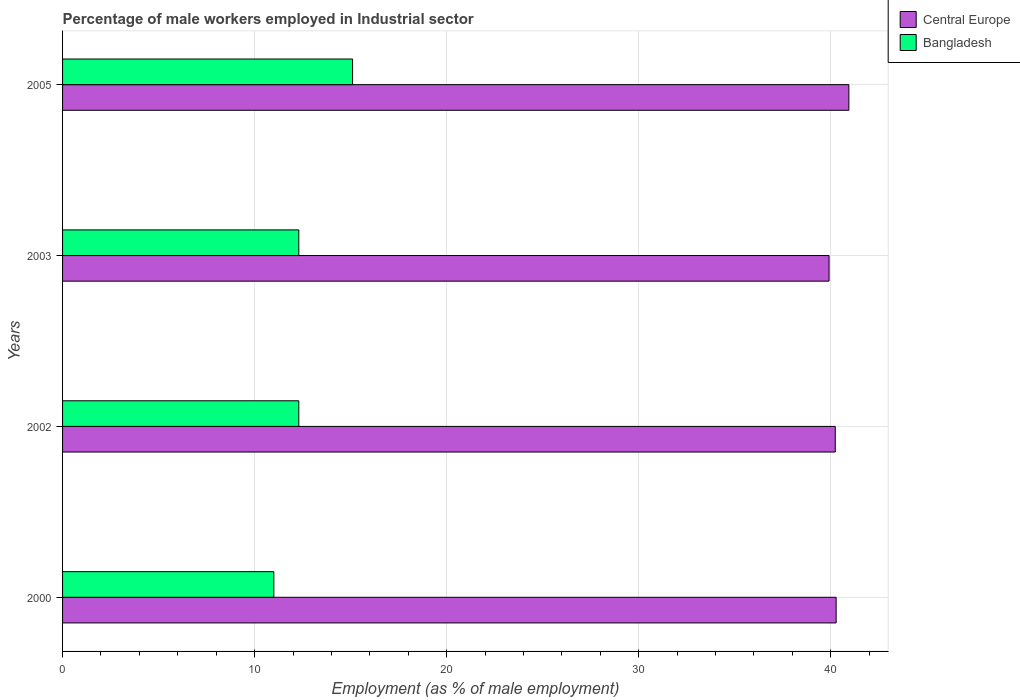How many groups of bars are there?
Provide a succinct answer. 4. Are the number of bars per tick equal to the number of legend labels?
Provide a succinct answer. Yes. In how many cases, is the number of bars for a given year not equal to the number of legend labels?
Make the answer very short. 0. What is the percentage of male workers employed in Industrial sector in Central Europe in 2005?
Offer a very short reply. 40.94. Across all years, what is the maximum percentage of male workers employed in Industrial sector in Bangladesh?
Your answer should be compact. 15.1. Across all years, what is the minimum percentage of male workers employed in Industrial sector in Central Europe?
Make the answer very short. 39.91. What is the total percentage of male workers employed in Industrial sector in Bangladesh in the graph?
Ensure brevity in your answer.  50.7. What is the difference between the percentage of male workers employed in Industrial sector in Bangladesh in 2003 and that in 2005?
Make the answer very short. -2.8. What is the difference between the percentage of male workers employed in Industrial sector in Bangladesh in 2000 and the percentage of male workers employed in Industrial sector in Central Europe in 2003?
Your response must be concise. -28.91. What is the average percentage of male workers employed in Industrial sector in Central Europe per year?
Make the answer very short. 40.34. In the year 2003, what is the difference between the percentage of male workers employed in Industrial sector in Bangladesh and percentage of male workers employed in Industrial sector in Central Europe?
Provide a succinct answer. -27.61. What is the ratio of the percentage of male workers employed in Industrial sector in Bangladesh in 2000 to that in 2002?
Your response must be concise. 0.89. Is the percentage of male workers employed in Industrial sector in Bangladesh in 2002 less than that in 2005?
Your answer should be compact. Yes. What is the difference between the highest and the second highest percentage of male workers employed in Industrial sector in Bangladesh?
Your response must be concise. 2.8. What is the difference between the highest and the lowest percentage of male workers employed in Industrial sector in Bangladesh?
Make the answer very short. 4.1. In how many years, is the percentage of male workers employed in Industrial sector in Bangladesh greater than the average percentage of male workers employed in Industrial sector in Bangladesh taken over all years?
Offer a very short reply. 1. What does the 2nd bar from the top in 2005 represents?
Ensure brevity in your answer.  Central Europe. What does the 2nd bar from the bottom in 2000 represents?
Make the answer very short. Bangladesh. How many years are there in the graph?
Ensure brevity in your answer.  4. Are the values on the major ticks of X-axis written in scientific E-notation?
Provide a succinct answer. No. Does the graph contain grids?
Give a very brief answer. Yes. Where does the legend appear in the graph?
Offer a terse response. Top right. How many legend labels are there?
Give a very brief answer. 2. What is the title of the graph?
Give a very brief answer. Percentage of male workers employed in Industrial sector. Does "Andorra" appear as one of the legend labels in the graph?
Ensure brevity in your answer.  No. What is the label or title of the X-axis?
Provide a short and direct response. Employment (as % of male employment). What is the Employment (as % of male employment) in Central Europe in 2000?
Give a very brief answer. 40.28. What is the Employment (as % of male employment) of Bangladesh in 2000?
Provide a short and direct response. 11. What is the Employment (as % of male employment) of Central Europe in 2002?
Make the answer very short. 40.23. What is the Employment (as % of male employment) of Bangladesh in 2002?
Keep it short and to the point. 12.3. What is the Employment (as % of male employment) in Central Europe in 2003?
Offer a very short reply. 39.91. What is the Employment (as % of male employment) of Bangladesh in 2003?
Give a very brief answer. 12.3. What is the Employment (as % of male employment) of Central Europe in 2005?
Keep it short and to the point. 40.94. What is the Employment (as % of male employment) in Bangladesh in 2005?
Make the answer very short. 15.1. Across all years, what is the maximum Employment (as % of male employment) of Central Europe?
Provide a succinct answer. 40.94. Across all years, what is the maximum Employment (as % of male employment) of Bangladesh?
Make the answer very short. 15.1. Across all years, what is the minimum Employment (as % of male employment) in Central Europe?
Provide a short and direct response. 39.91. What is the total Employment (as % of male employment) in Central Europe in the graph?
Provide a short and direct response. 161.36. What is the total Employment (as % of male employment) in Bangladesh in the graph?
Provide a short and direct response. 50.7. What is the difference between the Employment (as % of male employment) of Central Europe in 2000 and that in 2002?
Provide a succinct answer. 0.05. What is the difference between the Employment (as % of male employment) of Central Europe in 2000 and that in 2003?
Make the answer very short. 0.37. What is the difference between the Employment (as % of male employment) in Central Europe in 2000 and that in 2005?
Offer a very short reply. -0.66. What is the difference between the Employment (as % of male employment) of Bangladesh in 2000 and that in 2005?
Ensure brevity in your answer.  -4.1. What is the difference between the Employment (as % of male employment) in Central Europe in 2002 and that in 2003?
Give a very brief answer. 0.32. What is the difference between the Employment (as % of male employment) of Central Europe in 2002 and that in 2005?
Offer a terse response. -0.71. What is the difference between the Employment (as % of male employment) in Bangladesh in 2002 and that in 2005?
Provide a short and direct response. -2.8. What is the difference between the Employment (as % of male employment) of Central Europe in 2003 and that in 2005?
Your answer should be very brief. -1.03. What is the difference between the Employment (as % of male employment) of Central Europe in 2000 and the Employment (as % of male employment) of Bangladesh in 2002?
Make the answer very short. 27.98. What is the difference between the Employment (as % of male employment) in Central Europe in 2000 and the Employment (as % of male employment) in Bangladesh in 2003?
Offer a very short reply. 27.98. What is the difference between the Employment (as % of male employment) in Central Europe in 2000 and the Employment (as % of male employment) in Bangladesh in 2005?
Provide a succinct answer. 25.18. What is the difference between the Employment (as % of male employment) in Central Europe in 2002 and the Employment (as % of male employment) in Bangladesh in 2003?
Give a very brief answer. 27.93. What is the difference between the Employment (as % of male employment) in Central Europe in 2002 and the Employment (as % of male employment) in Bangladesh in 2005?
Offer a very short reply. 25.13. What is the difference between the Employment (as % of male employment) in Central Europe in 2003 and the Employment (as % of male employment) in Bangladesh in 2005?
Make the answer very short. 24.81. What is the average Employment (as % of male employment) in Central Europe per year?
Your response must be concise. 40.34. What is the average Employment (as % of male employment) of Bangladesh per year?
Ensure brevity in your answer.  12.68. In the year 2000, what is the difference between the Employment (as % of male employment) in Central Europe and Employment (as % of male employment) in Bangladesh?
Make the answer very short. 29.28. In the year 2002, what is the difference between the Employment (as % of male employment) in Central Europe and Employment (as % of male employment) in Bangladesh?
Keep it short and to the point. 27.93. In the year 2003, what is the difference between the Employment (as % of male employment) of Central Europe and Employment (as % of male employment) of Bangladesh?
Your answer should be compact. 27.61. In the year 2005, what is the difference between the Employment (as % of male employment) of Central Europe and Employment (as % of male employment) of Bangladesh?
Provide a succinct answer. 25.84. What is the ratio of the Employment (as % of male employment) of Central Europe in 2000 to that in 2002?
Make the answer very short. 1. What is the ratio of the Employment (as % of male employment) in Bangladesh in 2000 to that in 2002?
Your answer should be very brief. 0.89. What is the ratio of the Employment (as % of male employment) of Central Europe in 2000 to that in 2003?
Keep it short and to the point. 1.01. What is the ratio of the Employment (as % of male employment) in Bangladesh in 2000 to that in 2003?
Provide a succinct answer. 0.89. What is the ratio of the Employment (as % of male employment) of Central Europe in 2000 to that in 2005?
Make the answer very short. 0.98. What is the ratio of the Employment (as % of male employment) in Bangladesh in 2000 to that in 2005?
Keep it short and to the point. 0.73. What is the ratio of the Employment (as % of male employment) of Central Europe in 2002 to that in 2003?
Keep it short and to the point. 1.01. What is the ratio of the Employment (as % of male employment) of Bangladesh in 2002 to that in 2003?
Offer a very short reply. 1. What is the ratio of the Employment (as % of male employment) in Central Europe in 2002 to that in 2005?
Your answer should be compact. 0.98. What is the ratio of the Employment (as % of male employment) in Bangladesh in 2002 to that in 2005?
Keep it short and to the point. 0.81. What is the ratio of the Employment (as % of male employment) in Central Europe in 2003 to that in 2005?
Provide a short and direct response. 0.97. What is the ratio of the Employment (as % of male employment) in Bangladesh in 2003 to that in 2005?
Provide a succinct answer. 0.81. What is the difference between the highest and the second highest Employment (as % of male employment) of Central Europe?
Provide a short and direct response. 0.66. What is the difference between the highest and the second highest Employment (as % of male employment) in Bangladesh?
Provide a short and direct response. 2.8. What is the difference between the highest and the lowest Employment (as % of male employment) in Central Europe?
Give a very brief answer. 1.03. What is the difference between the highest and the lowest Employment (as % of male employment) of Bangladesh?
Make the answer very short. 4.1. 